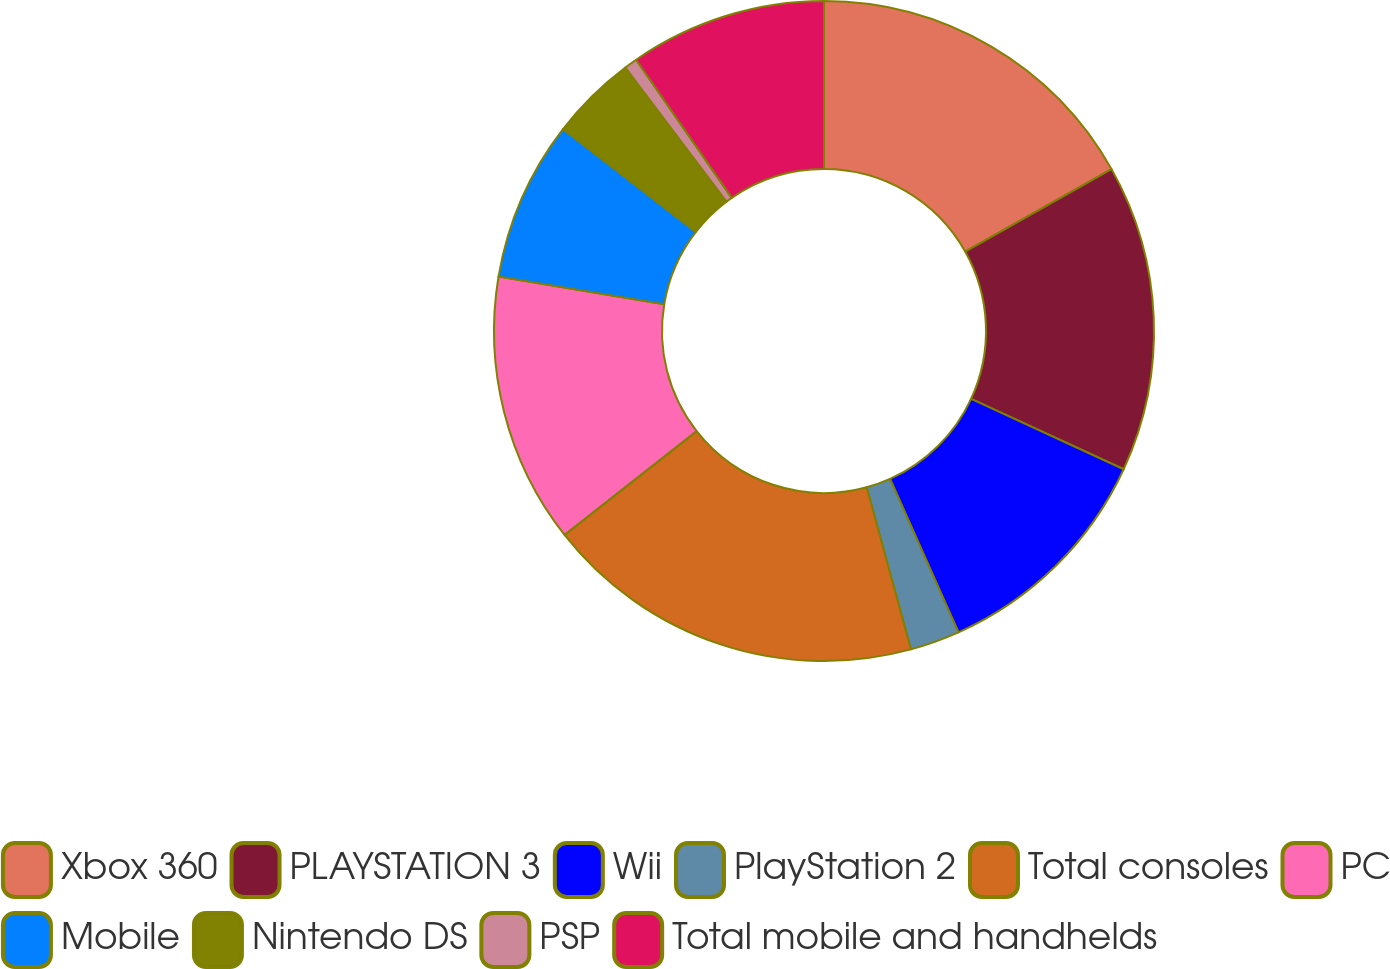Convert chart to OTSL. <chart><loc_0><loc_0><loc_500><loc_500><pie_chart><fcel>Xbox 360<fcel>PLAYSTATION 3<fcel>Wii<fcel>PlayStation 2<fcel>Total consoles<fcel>PC<fcel>Mobile<fcel>Nintendo DS<fcel>PSP<fcel>Total mobile and handhelds<nl><fcel>16.84%<fcel>15.04%<fcel>11.44%<fcel>2.44%<fcel>18.64%<fcel>13.24%<fcel>7.84%<fcel>4.24%<fcel>0.64%<fcel>9.64%<nl></chart> 